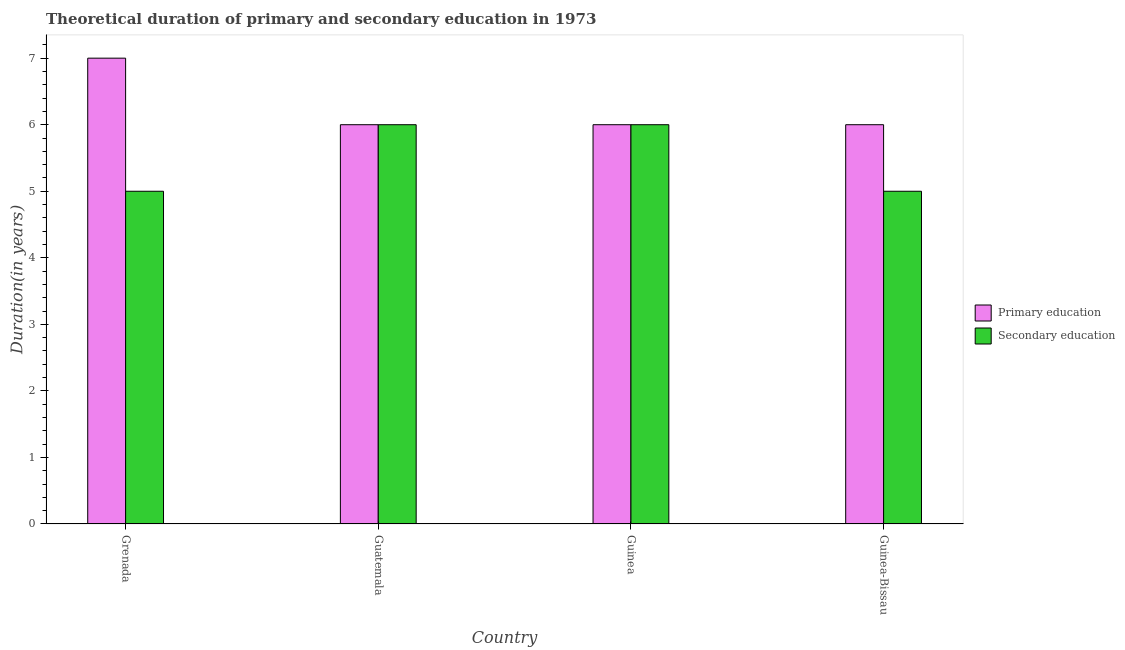How many different coloured bars are there?
Offer a terse response. 2. What is the label of the 4th group of bars from the left?
Your answer should be very brief. Guinea-Bissau. In how many cases, is the number of bars for a given country not equal to the number of legend labels?
Give a very brief answer. 0. What is the duration of secondary education in Guinea?
Make the answer very short. 6. Across all countries, what is the maximum duration of primary education?
Ensure brevity in your answer.  7. Across all countries, what is the minimum duration of secondary education?
Provide a short and direct response. 5. In which country was the duration of primary education maximum?
Your answer should be very brief. Grenada. In which country was the duration of primary education minimum?
Make the answer very short. Guatemala. What is the total duration of secondary education in the graph?
Ensure brevity in your answer.  22. What is the difference between the duration of secondary education in Grenada and that in Guinea-Bissau?
Provide a short and direct response. 0. What is the difference between the duration of primary education in Grenada and the duration of secondary education in Guatemala?
Offer a very short reply. 1. What is the average duration of secondary education per country?
Offer a very short reply. 5.5. What is the difference between the duration of primary education and duration of secondary education in Guinea?
Your answer should be very brief. 0. In how many countries, is the duration of secondary education greater than 0.4 years?
Provide a short and direct response. 4. What is the ratio of the duration of secondary education in Guinea to that in Guinea-Bissau?
Keep it short and to the point. 1.2. Is the difference between the duration of secondary education in Grenada and Guinea greater than the difference between the duration of primary education in Grenada and Guinea?
Give a very brief answer. No. What is the difference between the highest and the lowest duration of primary education?
Your answer should be very brief. 1. Is the sum of the duration of secondary education in Grenada and Guinea-Bissau greater than the maximum duration of primary education across all countries?
Keep it short and to the point. Yes. What does the 1st bar from the left in Guinea represents?
Your answer should be very brief. Primary education. What does the 2nd bar from the right in Guinea-Bissau represents?
Give a very brief answer. Primary education. How many countries are there in the graph?
Make the answer very short. 4. What is the difference between two consecutive major ticks on the Y-axis?
Make the answer very short. 1. Does the graph contain any zero values?
Your answer should be compact. No. What is the title of the graph?
Your response must be concise. Theoretical duration of primary and secondary education in 1973. What is the label or title of the X-axis?
Offer a very short reply. Country. What is the label or title of the Y-axis?
Keep it short and to the point. Duration(in years). What is the Duration(in years) in Secondary education in Guinea?
Offer a terse response. 6. What is the Duration(in years) in Primary education in Guinea-Bissau?
Offer a very short reply. 6. Across all countries, what is the maximum Duration(in years) in Secondary education?
Make the answer very short. 6. Across all countries, what is the minimum Duration(in years) in Primary education?
Your answer should be compact. 6. What is the total Duration(in years) of Secondary education in the graph?
Keep it short and to the point. 22. What is the difference between the Duration(in years) in Primary education in Grenada and that in Guatemala?
Provide a short and direct response. 1. What is the difference between the Duration(in years) in Primary education in Grenada and that in Guinea?
Make the answer very short. 1. What is the difference between the Duration(in years) in Secondary education in Grenada and that in Guinea?
Offer a very short reply. -1. What is the difference between the Duration(in years) in Primary education in Grenada and that in Guinea-Bissau?
Offer a terse response. 1. What is the difference between the Duration(in years) in Secondary education in Grenada and that in Guinea-Bissau?
Provide a short and direct response. 0. What is the difference between the Duration(in years) of Secondary education in Guatemala and that in Guinea-Bissau?
Provide a short and direct response. 1. What is the difference between the Duration(in years) in Secondary education in Guinea and that in Guinea-Bissau?
Provide a short and direct response. 1. What is the difference between the Duration(in years) in Primary education in Grenada and the Duration(in years) in Secondary education in Guatemala?
Provide a succinct answer. 1. What is the difference between the Duration(in years) in Primary education in Grenada and the Duration(in years) in Secondary education in Guinea?
Your response must be concise. 1. What is the difference between the Duration(in years) in Primary education in Grenada and the Duration(in years) in Secondary education in Guinea-Bissau?
Give a very brief answer. 2. What is the difference between the Duration(in years) of Primary education in Guatemala and the Duration(in years) of Secondary education in Guinea?
Provide a short and direct response. 0. What is the difference between the Duration(in years) in Primary education in Guatemala and the Duration(in years) in Secondary education in Guinea-Bissau?
Your answer should be compact. 1. What is the average Duration(in years) of Primary education per country?
Your response must be concise. 6.25. What is the difference between the Duration(in years) of Primary education and Duration(in years) of Secondary education in Guatemala?
Ensure brevity in your answer.  0. What is the difference between the Duration(in years) in Primary education and Duration(in years) in Secondary education in Guinea-Bissau?
Keep it short and to the point. 1. What is the ratio of the Duration(in years) in Primary education in Grenada to that in Guinea?
Ensure brevity in your answer.  1.17. What is the ratio of the Duration(in years) of Primary education in Grenada to that in Guinea-Bissau?
Provide a succinct answer. 1.17. What is the ratio of the Duration(in years) of Primary education in Guatemala to that in Guinea?
Your answer should be very brief. 1. What is the ratio of the Duration(in years) of Primary education in Guatemala to that in Guinea-Bissau?
Give a very brief answer. 1. What is the ratio of the Duration(in years) in Primary education in Guinea to that in Guinea-Bissau?
Offer a terse response. 1. What is the difference between the highest and the second highest Duration(in years) of Primary education?
Make the answer very short. 1. What is the difference between the highest and the lowest Duration(in years) in Primary education?
Provide a succinct answer. 1. 